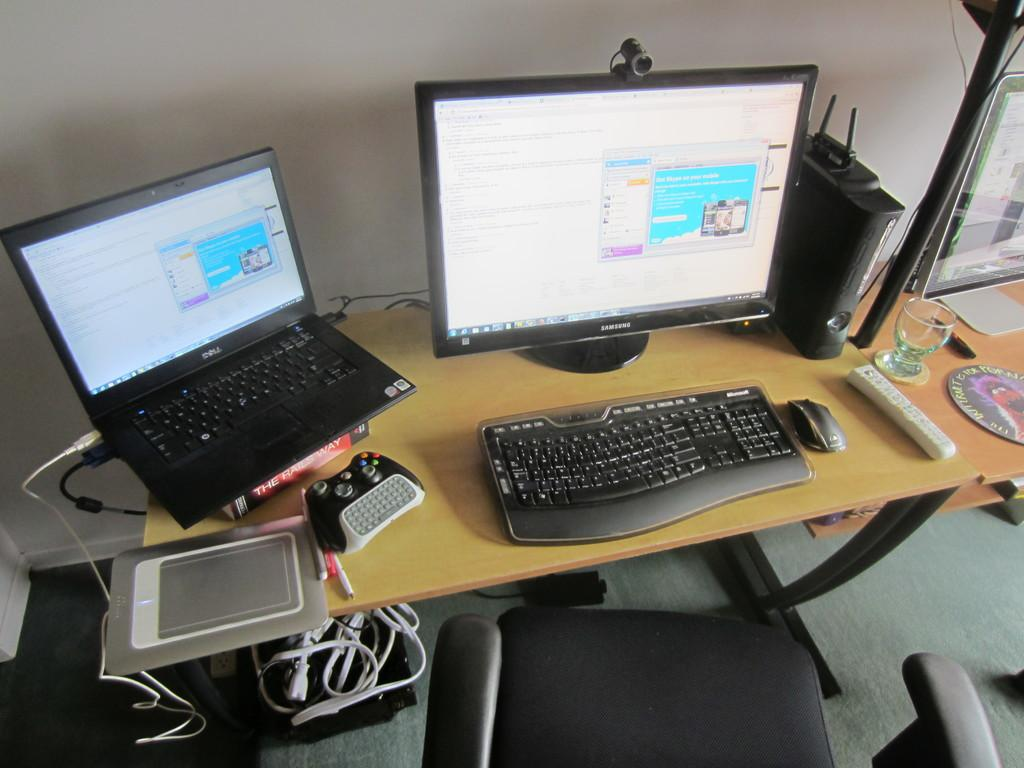What electronic device is on the table in the image? There is a laptop on the table in the image. What other computer peripherals are on the table? There is a monitor, a keyboard, and a mouse on the table. Are there any cables visible in the image? Yes, there are cables visible in the image. What type of furniture is near the table? There is a chair near the table. What type of apple is being used as a brake in the image? There is no apple or brake present in the image. What is the selection of fruits on the table in the image? There is no mention of fruits in the image; the focus is on computer peripherals and a chair. 